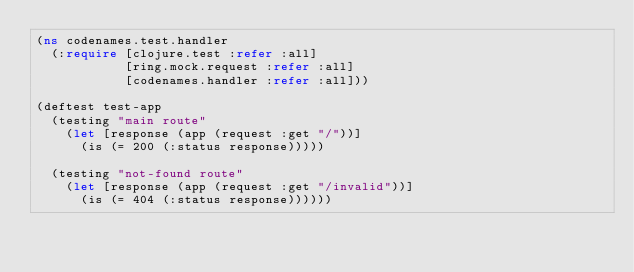Convert code to text. <code><loc_0><loc_0><loc_500><loc_500><_Clojure_>(ns codenames.test.handler
  (:require [clojure.test :refer :all]
            [ring.mock.request :refer :all]
            [codenames.handler :refer :all]))

(deftest test-app
  (testing "main route"
    (let [response (app (request :get "/"))]
      (is (= 200 (:status response)))))

  (testing "not-found route"
    (let [response (app (request :get "/invalid"))]
      (is (= 404 (:status response))))))
</code> 